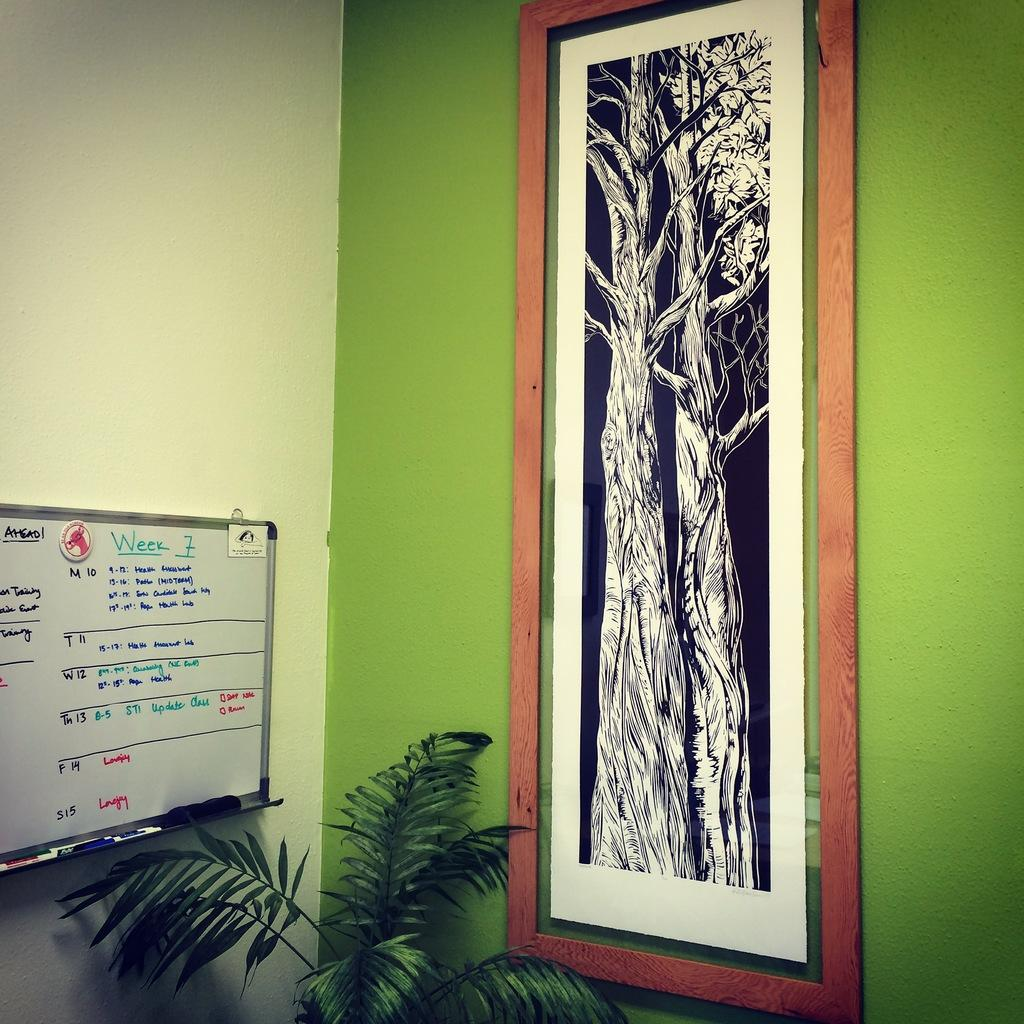What is the main feature in the center of the image? There is a wall in the center of the image. What is located near the wall? There is a plant near the wall. What can be seen on the wall? There is a frame and a board on the wall. What is written on the board? There is text on the board. What else is on the board besides text? There are objects on the board. How does the sleet affect the plant in the image? There is no sleet present in the image, so it cannot affect the plant. What type of stitch is used to attach the objects to the board? There is no stitching visible in the image, as the objects are likely attached with adhesive or another method. 